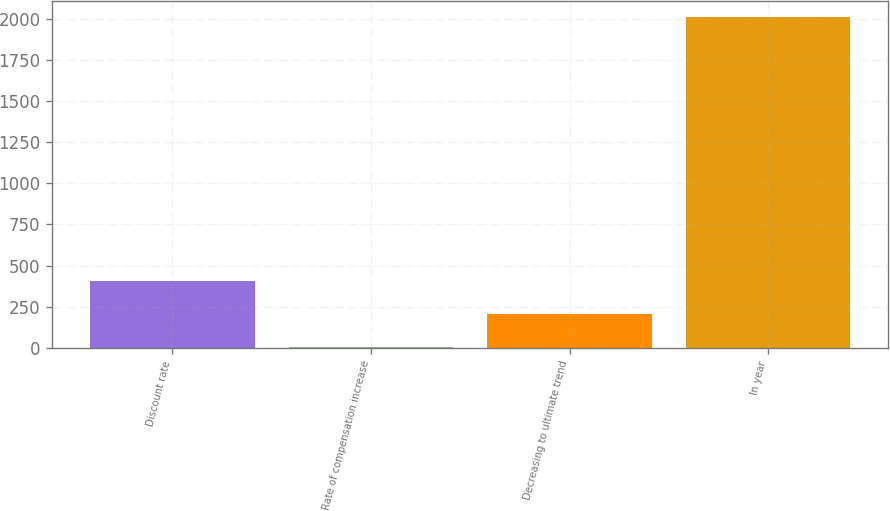Convert chart. <chart><loc_0><loc_0><loc_500><loc_500><bar_chart><fcel>Discount rate<fcel>Rate of compensation increase<fcel>Decreasing to ultimate trend<fcel>In year<nl><fcel>404.81<fcel>3.75<fcel>204.28<fcel>2009<nl></chart> 